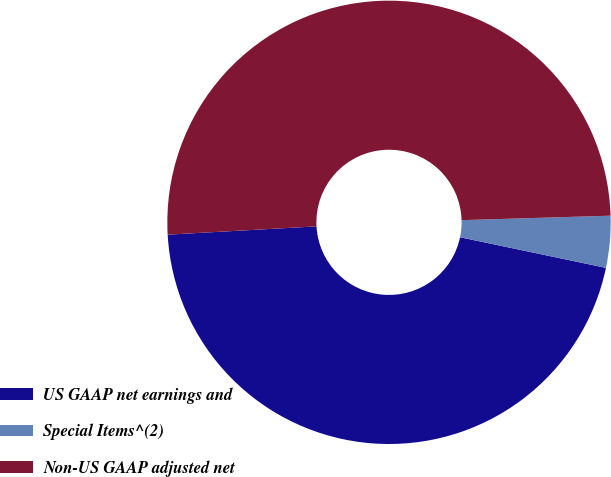Convert chart to OTSL. <chart><loc_0><loc_0><loc_500><loc_500><pie_chart><fcel>US GAAP net earnings and<fcel>Special Items^(2)<fcel>Non-US GAAP adjusted net<nl><fcel>45.82%<fcel>3.77%<fcel>50.41%<nl></chart> 